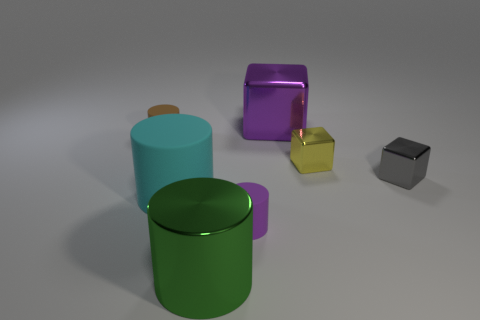Subtract all purple cylinders. How many cylinders are left? 3 Subtract 2 cylinders. How many cylinders are left? 2 Subtract all large cyan cylinders. How many cylinders are left? 3 Add 2 gray things. How many objects exist? 9 Subtract all blue cylinders. Subtract all yellow cubes. How many cylinders are left? 4 Subtract all blocks. How many objects are left? 4 Subtract all small yellow rubber cylinders. Subtract all purple rubber cylinders. How many objects are left? 6 Add 7 small purple things. How many small purple things are left? 8 Add 5 purple shiny cubes. How many purple shiny cubes exist? 6 Subtract 1 green cylinders. How many objects are left? 6 